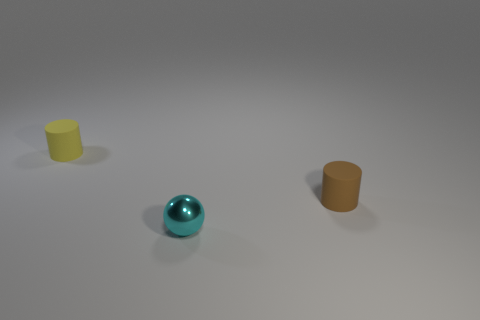Subtract 1 balls. How many balls are left? 0 Subtract all cylinders. How many objects are left? 1 Add 3 tiny brown metal blocks. How many objects exist? 6 Add 2 yellow matte cylinders. How many yellow matte cylinders exist? 3 Subtract 0 yellow blocks. How many objects are left? 3 Subtract all purple cylinders. Subtract all yellow spheres. How many cylinders are left? 2 Subtract all small cyan metallic things. Subtract all yellow rubber cylinders. How many objects are left? 1 Add 2 cyan shiny spheres. How many cyan shiny spheres are left? 3 